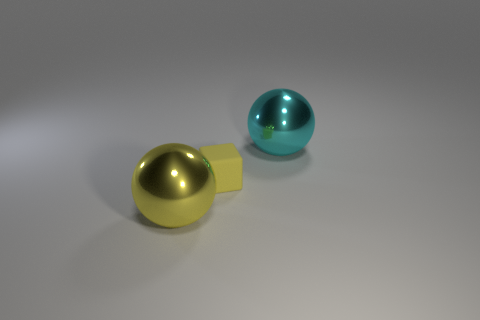Add 2 metal spheres. How many objects exist? 5 Subtract all balls. How many objects are left? 1 Add 3 yellow matte objects. How many yellow matte objects exist? 4 Subtract 0 brown blocks. How many objects are left? 3 Subtract all large cyan balls. Subtract all big cyan metal objects. How many objects are left? 1 Add 3 cyan spheres. How many cyan spheres are left? 4 